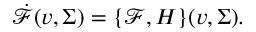<formula> <loc_0><loc_0><loc_500><loc_500>\dot { \mathcal { F } } ( v , \Sigma ) = \{ \mathcal { F } , H \} ( v , \Sigma ) .</formula> 